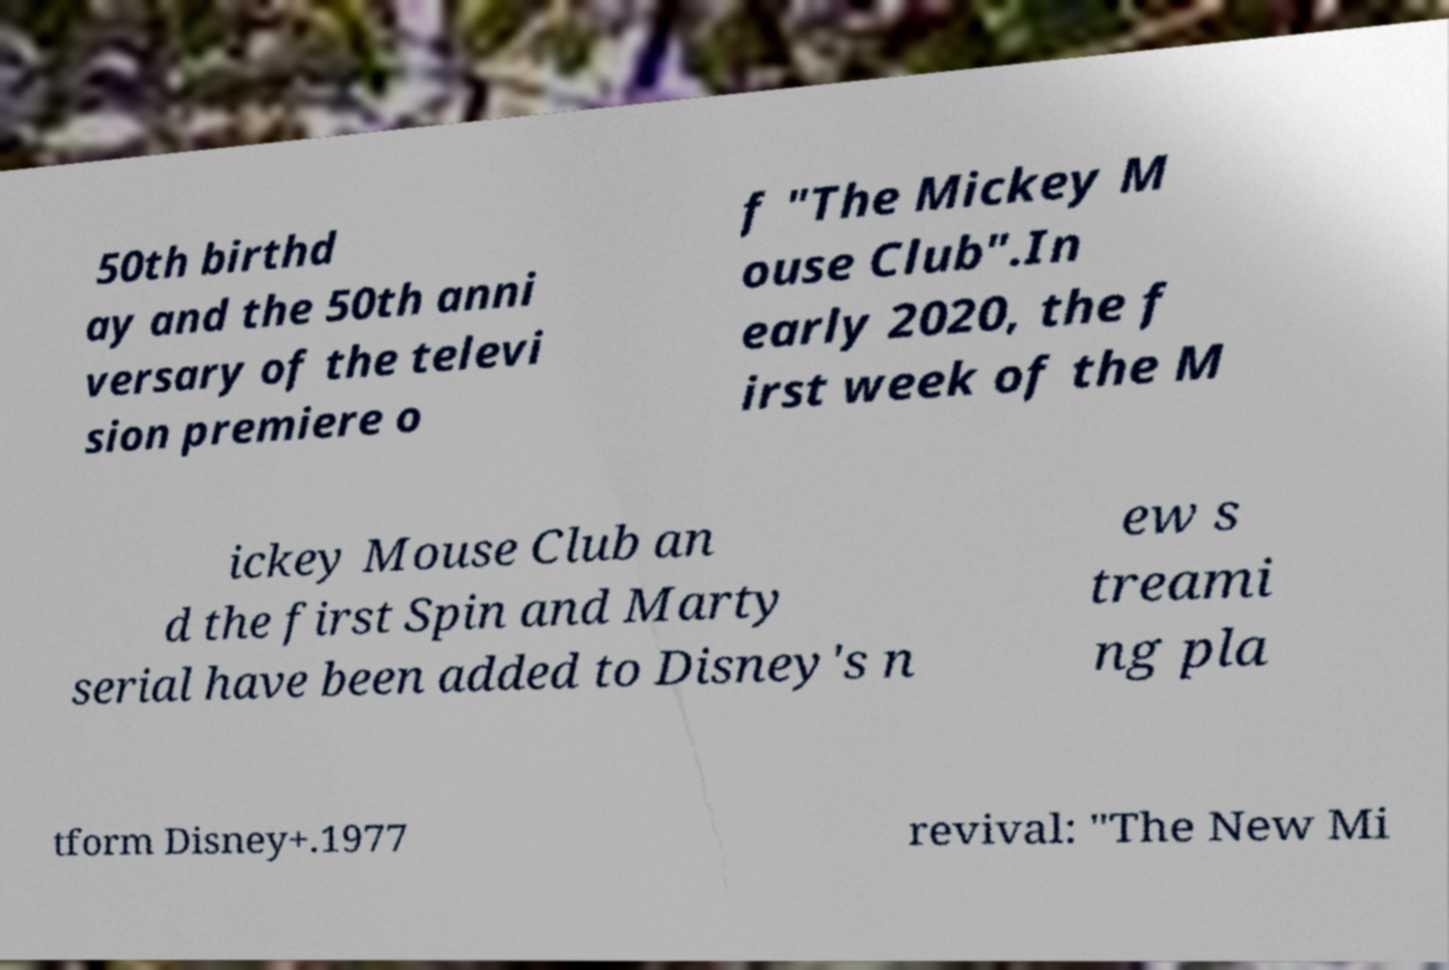There's text embedded in this image that I need extracted. Can you transcribe it verbatim? 50th birthd ay and the 50th anni versary of the televi sion premiere o f "The Mickey M ouse Club".In early 2020, the f irst week of the M ickey Mouse Club an d the first Spin and Marty serial have been added to Disney's n ew s treami ng pla tform Disney+.1977 revival: "The New Mi 